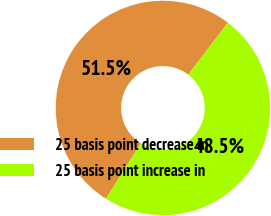Convert chart. <chart><loc_0><loc_0><loc_500><loc_500><pie_chart><fcel>25 basis point decrease in<fcel>25 basis point increase in<nl><fcel>51.46%<fcel>48.54%<nl></chart> 